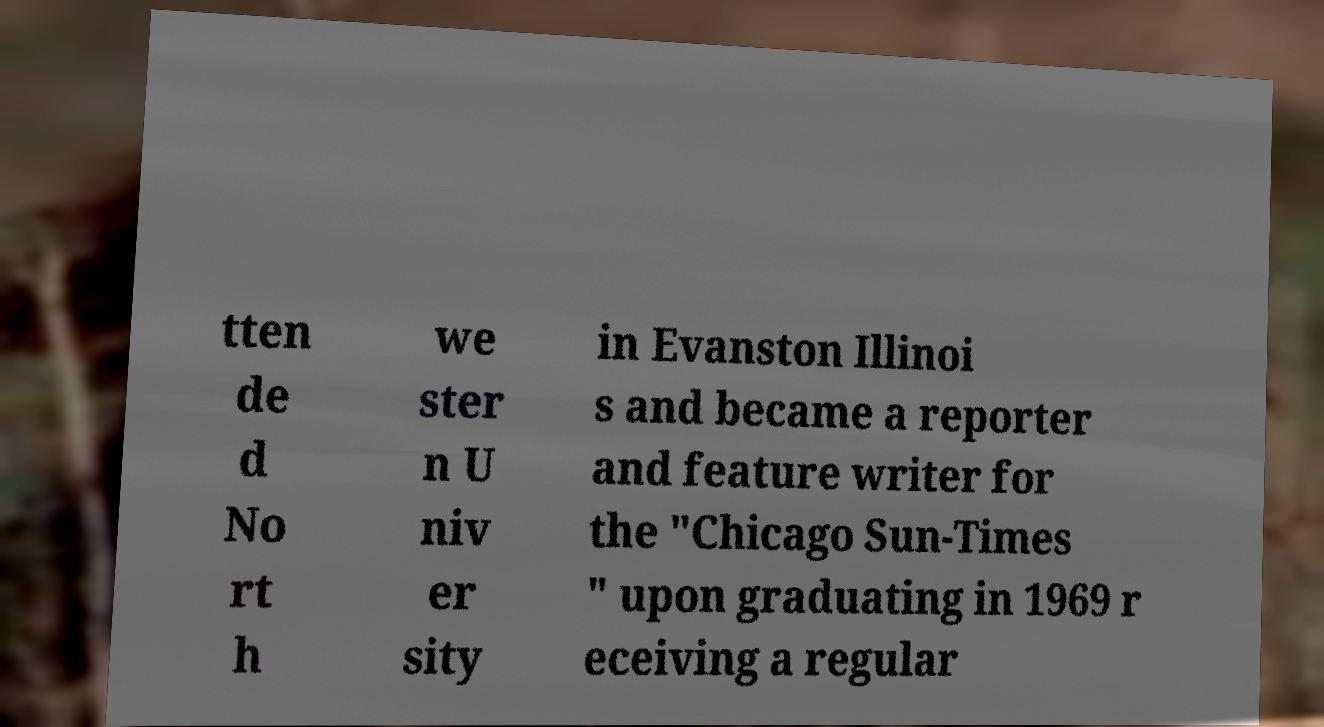Please read and relay the text visible in this image. What does it say? tten de d No rt h we ster n U niv er sity in Evanston Illinoi s and became a reporter and feature writer for the "Chicago Sun-Times " upon graduating in 1969 r eceiving a regular 